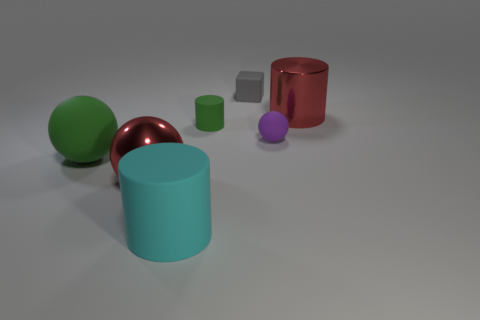Subtract 1 spheres. How many spheres are left? 2 Subtract all small cylinders. How many cylinders are left? 2 Add 3 green objects. How many objects exist? 10 Subtract all balls. How many objects are left? 4 Subtract 1 gray cubes. How many objects are left? 6 Subtract all red cylinders. Subtract all green rubber cylinders. How many objects are left? 5 Add 7 big green spheres. How many big green spheres are left? 8 Add 7 green balls. How many green balls exist? 8 